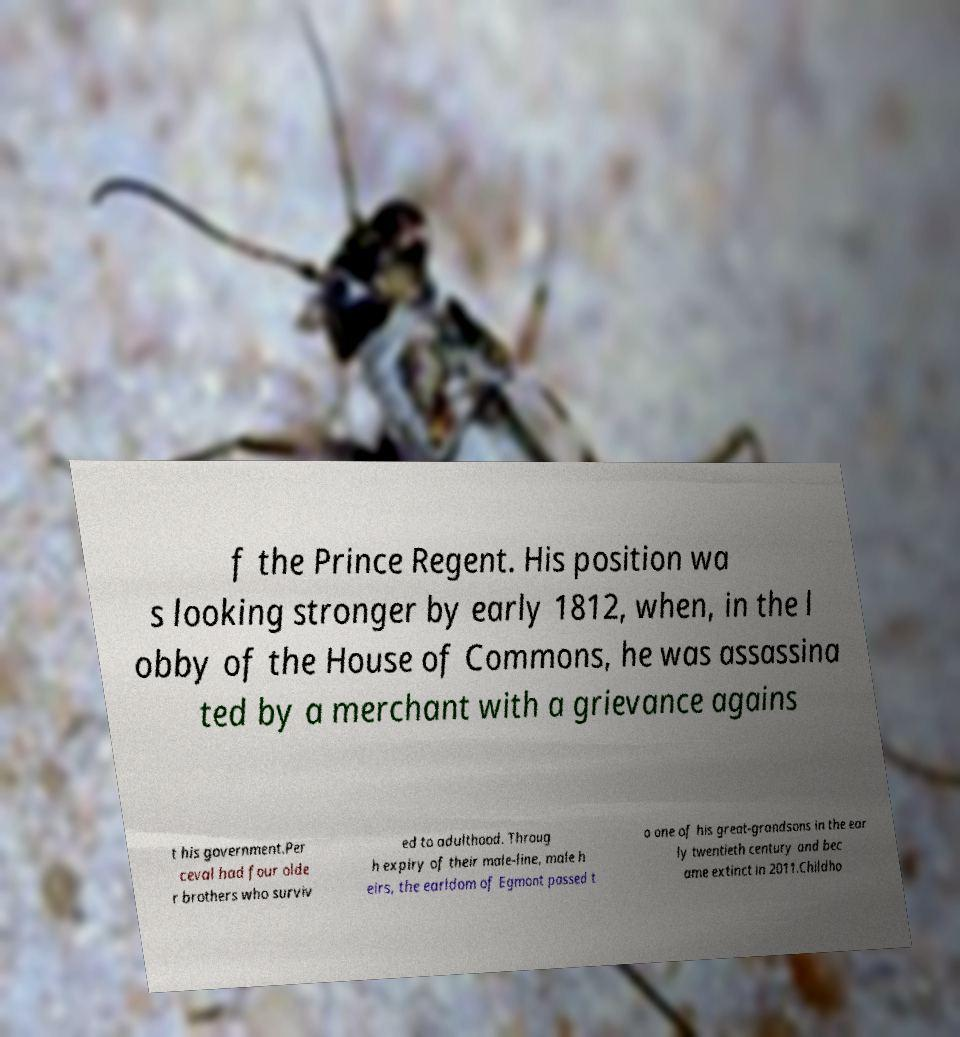Please identify and transcribe the text found in this image. f the Prince Regent. His position wa s looking stronger by early 1812, when, in the l obby of the House of Commons, he was assassina ted by a merchant with a grievance agains t his government.Per ceval had four olde r brothers who surviv ed to adulthood. Throug h expiry of their male-line, male h eirs, the earldom of Egmont passed t o one of his great-grandsons in the ear ly twentieth century and bec ame extinct in 2011.Childho 